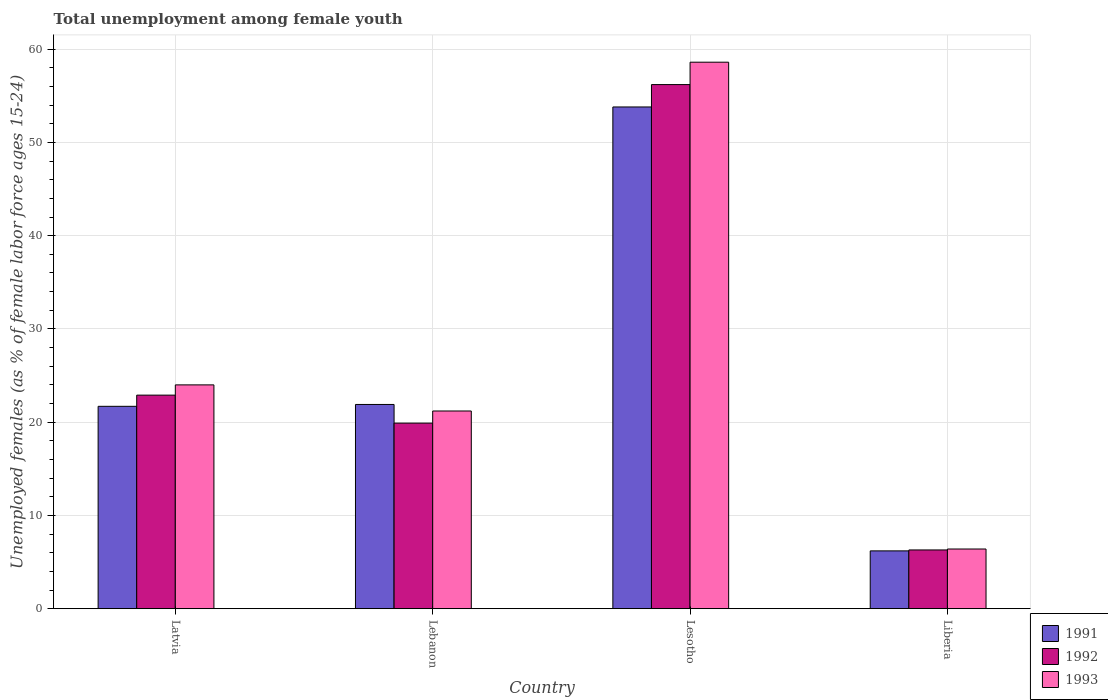How many different coloured bars are there?
Provide a short and direct response. 3. Are the number of bars per tick equal to the number of legend labels?
Offer a very short reply. Yes. How many bars are there on the 4th tick from the left?
Provide a short and direct response. 3. How many bars are there on the 1st tick from the right?
Provide a succinct answer. 3. What is the label of the 2nd group of bars from the left?
Make the answer very short. Lebanon. In how many cases, is the number of bars for a given country not equal to the number of legend labels?
Provide a succinct answer. 0. What is the percentage of unemployed females in in 1991 in Latvia?
Give a very brief answer. 21.7. Across all countries, what is the maximum percentage of unemployed females in in 1992?
Offer a very short reply. 56.2. Across all countries, what is the minimum percentage of unemployed females in in 1993?
Offer a very short reply. 6.4. In which country was the percentage of unemployed females in in 1993 maximum?
Offer a very short reply. Lesotho. In which country was the percentage of unemployed females in in 1991 minimum?
Your answer should be very brief. Liberia. What is the total percentage of unemployed females in in 1992 in the graph?
Your response must be concise. 105.3. What is the difference between the percentage of unemployed females in in 1992 in Latvia and that in Lebanon?
Provide a succinct answer. 3. What is the difference between the percentage of unemployed females in in 1991 in Lebanon and the percentage of unemployed females in in 1993 in Latvia?
Your answer should be very brief. -2.1. What is the average percentage of unemployed females in in 1993 per country?
Your answer should be compact. 27.55. What is the difference between the percentage of unemployed females in of/in 1991 and percentage of unemployed females in of/in 1992 in Liberia?
Make the answer very short. -0.1. In how many countries, is the percentage of unemployed females in in 1991 greater than 52 %?
Your response must be concise. 1. What is the ratio of the percentage of unemployed females in in 1993 in Latvia to that in Lebanon?
Give a very brief answer. 1.13. Is the percentage of unemployed females in in 1993 in Lesotho less than that in Liberia?
Ensure brevity in your answer.  No. What is the difference between the highest and the second highest percentage of unemployed females in in 1992?
Offer a very short reply. 36.3. What is the difference between the highest and the lowest percentage of unemployed females in in 1993?
Provide a short and direct response. 52.2. Is it the case that in every country, the sum of the percentage of unemployed females in in 1991 and percentage of unemployed females in in 1993 is greater than the percentage of unemployed females in in 1992?
Give a very brief answer. Yes. Are all the bars in the graph horizontal?
Ensure brevity in your answer.  No. How many countries are there in the graph?
Provide a succinct answer. 4. What is the difference between two consecutive major ticks on the Y-axis?
Offer a very short reply. 10. Does the graph contain grids?
Provide a short and direct response. Yes. Where does the legend appear in the graph?
Offer a terse response. Bottom right. How many legend labels are there?
Your response must be concise. 3. What is the title of the graph?
Your response must be concise. Total unemployment among female youth. What is the label or title of the Y-axis?
Make the answer very short. Unemployed females (as % of female labor force ages 15-24). What is the Unemployed females (as % of female labor force ages 15-24) in 1991 in Latvia?
Make the answer very short. 21.7. What is the Unemployed females (as % of female labor force ages 15-24) of 1992 in Latvia?
Make the answer very short. 22.9. What is the Unemployed females (as % of female labor force ages 15-24) in 1991 in Lebanon?
Make the answer very short. 21.9. What is the Unemployed females (as % of female labor force ages 15-24) of 1992 in Lebanon?
Your response must be concise. 19.9. What is the Unemployed females (as % of female labor force ages 15-24) in 1993 in Lebanon?
Offer a terse response. 21.2. What is the Unemployed females (as % of female labor force ages 15-24) in 1991 in Lesotho?
Your response must be concise. 53.8. What is the Unemployed females (as % of female labor force ages 15-24) in 1992 in Lesotho?
Your answer should be compact. 56.2. What is the Unemployed females (as % of female labor force ages 15-24) in 1993 in Lesotho?
Make the answer very short. 58.6. What is the Unemployed females (as % of female labor force ages 15-24) in 1991 in Liberia?
Offer a terse response. 6.2. What is the Unemployed females (as % of female labor force ages 15-24) of 1992 in Liberia?
Provide a succinct answer. 6.3. What is the Unemployed females (as % of female labor force ages 15-24) in 1993 in Liberia?
Ensure brevity in your answer.  6.4. Across all countries, what is the maximum Unemployed females (as % of female labor force ages 15-24) in 1991?
Keep it short and to the point. 53.8. Across all countries, what is the maximum Unemployed females (as % of female labor force ages 15-24) in 1992?
Ensure brevity in your answer.  56.2. Across all countries, what is the maximum Unemployed females (as % of female labor force ages 15-24) of 1993?
Your response must be concise. 58.6. Across all countries, what is the minimum Unemployed females (as % of female labor force ages 15-24) of 1991?
Your response must be concise. 6.2. Across all countries, what is the minimum Unemployed females (as % of female labor force ages 15-24) of 1992?
Keep it short and to the point. 6.3. Across all countries, what is the minimum Unemployed females (as % of female labor force ages 15-24) in 1993?
Make the answer very short. 6.4. What is the total Unemployed females (as % of female labor force ages 15-24) of 1991 in the graph?
Offer a terse response. 103.6. What is the total Unemployed females (as % of female labor force ages 15-24) in 1992 in the graph?
Make the answer very short. 105.3. What is the total Unemployed females (as % of female labor force ages 15-24) of 1993 in the graph?
Provide a short and direct response. 110.2. What is the difference between the Unemployed females (as % of female labor force ages 15-24) of 1991 in Latvia and that in Lebanon?
Offer a very short reply. -0.2. What is the difference between the Unemployed females (as % of female labor force ages 15-24) of 1991 in Latvia and that in Lesotho?
Give a very brief answer. -32.1. What is the difference between the Unemployed females (as % of female labor force ages 15-24) of 1992 in Latvia and that in Lesotho?
Offer a terse response. -33.3. What is the difference between the Unemployed females (as % of female labor force ages 15-24) in 1993 in Latvia and that in Lesotho?
Offer a very short reply. -34.6. What is the difference between the Unemployed females (as % of female labor force ages 15-24) of 1991 in Lebanon and that in Lesotho?
Keep it short and to the point. -31.9. What is the difference between the Unemployed females (as % of female labor force ages 15-24) of 1992 in Lebanon and that in Lesotho?
Make the answer very short. -36.3. What is the difference between the Unemployed females (as % of female labor force ages 15-24) of 1993 in Lebanon and that in Lesotho?
Provide a succinct answer. -37.4. What is the difference between the Unemployed females (as % of female labor force ages 15-24) of 1991 in Lebanon and that in Liberia?
Offer a very short reply. 15.7. What is the difference between the Unemployed females (as % of female labor force ages 15-24) in 1992 in Lebanon and that in Liberia?
Your answer should be compact. 13.6. What is the difference between the Unemployed females (as % of female labor force ages 15-24) in 1993 in Lebanon and that in Liberia?
Give a very brief answer. 14.8. What is the difference between the Unemployed females (as % of female labor force ages 15-24) in 1991 in Lesotho and that in Liberia?
Offer a very short reply. 47.6. What is the difference between the Unemployed females (as % of female labor force ages 15-24) in 1992 in Lesotho and that in Liberia?
Provide a short and direct response. 49.9. What is the difference between the Unemployed females (as % of female labor force ages 15-24) of 1993 in Lesotho and that in Liberia?
Offer a very short reply. 52.2. What is the difference between the Unemployed females (as % of female labor force ages 15-24) in 1991 in Latvia and the Unemployed females (as % of female labor force ages 15-24) in 1992 in Lebanon?
Give a very brief answer. 1.8. What is the difference between the Unemployed females (as % of female labor force ages 15-24) of 1991 in Latvia and the Unemployed females (as % of female labor force ages 15-24) of 1993 in Lebanon?
Your answer should be compact. 0.5. What is the difference between the Unemployed females (as % of female labor force ages 15-24) of 1991 in Latvia and the Unemployed females (as % of female labor force ages 15-24) of 1992 in Lesotho?
Provide a short and direct response. -34.5. What is the difference between the Unemployed females (as % of female labor force ages 15-24) in 1991 in Latvia and the Unemployed females (as % of female labor force ages 15-24) in 1993 in Lesotho?
Offer a terse response. -36.9. What is the difference between the Unemployed females (as % of female labor force ages 15-24) in 1992 in Latvia and the Unemployed females (as % of female labor force ages 15-24) in 1993 in Lesotho?
Your answer should be very brief. -35.7. What is the difference between the Unemployed females (as % of female labor force ages 15-24) in 1991 in Latvia and the Unemployed females (as % of female labor force ages 15-24) in 1992 in Liberia?
Offer a very short reply. 15.4. What is the difference between the Unemployed females (as % of female labor force ages 15-24) of 1991 in Latvia and the Unemployed females (as % of female labor force ages 15-24) of 1993 in Liberia?
Give a very brief answer. 15.3. What is the difference between the Unemployed females (as % of female labor force ages 15-24) in 1992 in Latvia and the Unemployed females (as % of female labor force ages 15-24) in 1993 in Liberia?
Offer a very short reply. 16.5. What is the difference between the Unemployed females (as % of female labor force ages 15-24) in 1991 in Lebanon and the Unemployed females (as % of female labor force ages 15-24) in 1992 in Lesotho?
Offer a very short reply. -34.3. What is the difference between the Unemployed females (as % of female labor force ages 15-24) of 1991 in Lebanon and the Unemployed females (as % of female labor force ages 15-24) of 1993 in Lesotho?
Provide a succinct answer. -36.7. What is the difference between the Unemployed females (as % of female labor force ages 15-24) of 1992 in Lebanon and the Unemployed females (as % of female labor force ages 15-24) of 1993 in Lesotho?
Your response must be concise. -38.7. What is the difference between the Unemployed females (as % of female labor force ages 15-24) in 1991 in Lesotho and the Unemployed females (as % of female labor force ages 15-24) in 1992 in Liberia?
Keep it short and to the point. 47.5. What is the difference between the Unemployed females (as % of female labor force ages 15-24) in 1991 in Lesotho and the Unemployed females (as % of female labor force ages 15-24) in 1993 in Liberia?
Provide a succinct answer. 47.4. What is the difference between the Unemployed females (as % of female labor force ages 15-24) in 1992 in Lesotho and the Unemployed females (as % of female labor force ages 15-24) in 1993 in Liberia?
Offer a very short reply. 49.8. What is the average Unemployed females (as % of female labor force ages 15-24) in 1991 per country?
Keep it short and to the point. 25.9. What is the average Unemployed females (as % of female labor force ages 15-24) of 1992 per country?
Offer a very short reply. 26.32. What is the average Unemployed females (as % of female labor force ages 15-24) in 1993 per country?
Ensure brevity in your answer.  27.55. What is the difference between the Unemployed females (as % of female labor force ages 15-24) in 1991 and Unemployed females (as % of female labor force ages 15-24) in 1992 in Latvia?
Ensure brevity in your answer.  -1.2. What is the difference between the Unemployed females (as % of female labor force ages 15-24) of 1991 and Unemployed females (as % of female labor force ages 15-24) of 1992 in Lebanon?
Keep it short and to the point. 2. What is the difference between the Unemployed females (as % of female labor force ages 15-24) in 1991 and Unemployed females (as % of female labor force ages 15-24) in 1993 in Lebanon?
Offer a very short reply. 0.7. What is the difference between the Unemployed females (as % of female labor force ages 15-24) of 1992 and Unemployed females (as % of female labor force ages 15-24) of 1993 in Lebanon?
Ensure brevity in your answer.  -1.3. What is the difference between the Unemployed females (as % of female labor force ages 15-24) of 1991 and Unemployed females (as % of female labor force ages 15-24) of 1993 in Lesotho?
Make the answer very short. -4.8. What is the difference between the Unemployed females (as % of female labor force ages 15-24) in 1992 and Unemployed females (as % of female labor force ages 15-24) in 1993 in Lesotho?
Your answer should be very brief. -2.4. What is the difference between the Unemployed females (as % of female labor force ages 15-24) in 1992 and Unemployed females (as % of female labor force ages 15-24) in 1993 in Liberia?
Your answer should be compact. -0.1. What is the ratio of the Unemployed females (as % of female labor force ages 15-24) of 1991 in Latvia to that in Lebanon?
Ensure brevity in your answer.  0.99. What is the ratio of the Unemployed females (as % of female labor force ages 15-24) of 1992 in Latvia to that in Lebanon?
Give a very brief answer. 1.15. What is the ratio of the Unemployed females (as % of female labor force ages 15-24) of 1993 in Latvia to that in Lebanon?
Ensure brevity in your answer.  1.13. What is the ratio of the Unemployed females (as % of female labor force ages 15-24) in 1991 in Latvia to that in Lesotho?
Your response must be concise. 0.4. What is the ratio of the Unemployed females (as % of female labor force ages 15-24) in 1992 in Latvia to that in Lesotho?
Offer a terse response. 0.41. What is the ratio of the Unemployed females (as % of female labor force ages 15-24) of 1993 in Latvia to that in Lesotho?
Offer a terse response. 0.41. What is the ratio of the Unemployed females (as % of female labor force ages 15-24) of 1991 in Latvia to that in Liberia?
Provide a succinct answer. 3.5. What is the ratio of the Unemployed females (as % of female labor force ages 15-24) in 1992 in Latvia to that in Liberia?
Provide a short and direct response. 3.63. What is the ratio of the Unemployed females (as % of female labor force ages 15-24) of 1993 in Latvia to that in Liberia?
Provide a succinct answer. 3.75. What is the ratio of the Unemployed females (as % of female labor force ages 15-24) of 1991 in Lebanon to that in Lesotho?
Your answer should be very brief. 0.41. What is the ratio of the Unemployed females (as % of female labor force ages 15-24) in 1992 in Lebanon to that in Lesotho?
Provide a succinct answer. 0.35. What is the ratio of the Unemployed females (as % of female labor force ages 15-24) of 1993 in Lebanon to that in Lesotho?
Offer a very short reply. 0.36. What is the ratio of the Unemployed females (as % of female labor force ages 15-24) of 1991 in Lebanon to that in Liberia?
Make the answer very short. 3.53. What is the ratio of the Unemployed females (as % of female labor force ages 15-24) of 1992 in Lebanon to that in Liberia?
Make the answer very short. 3.16. What is the ratio of the Unemployed females (as % of female labor force ages 15-24) in 1993 in Lebanon to that in Liberia?
Your answer should be very brief. 3.31. What is the ratio of the Unemployed females (as % of female labor force ages 15-24) in 1991 in Lesotho to that in Liberia?
Give a very brief answer. 8.68. What is the ratio of the Unemployed females (as % of female labor force ages 15-24) in 1992 in Lesotho to that in Liberia?
Your response must be concise. 8.92. What is the ratio of the Unemployed females (as % of female labor force ages 15-24) in 1993 in Lesotho to that in Liberia?
Provide a short and direct response. 9.16. What is the difference between the highest and the second highest Unemployed females (as % of female labor force ages 15-24) in 1991?
Keep it short and to the point. 31.9. What is the difference between the highest and the second highest Unemployed females (as % of female labor force ages 15-24) of 1992?
Offer a very short reply. 33.3. What is the difference between the highest and the second highest Unemployed females (as % of female labor force ages 15-24) of 1993?
Your response must be concise. 34.6. What is the difference between the highest and the lowest Unemployed females (as % of female labor force ages 15-24) of 1991?
Keep it short and to the point. 47.6. What is the difference between the highest and the lowest Unemployed females (as % of female labor force ages 15-24) in 1992?
Provide a short and direct response. 49.9. What is the difference between the highest and the lowest Unemployed females (as % of female labor force ages 15-24) in 1993?
Make the answer very short. 52.2. 